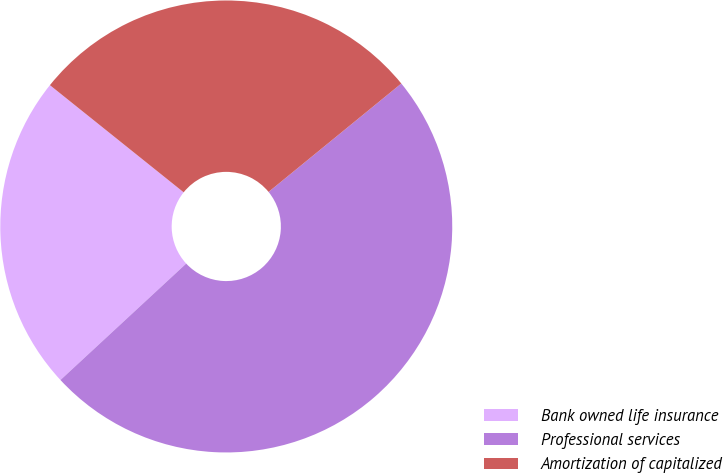Convert chart. <chart><loc_0><loc_0><loc_500><loc_500><pie_chart><fcel>Bank owned life insurance<fcel>Professional services<fcel>Amortization of capitalized<nl><fcel>22.64%<fcel>49.01%<fcel>28.35%<nl></chart> 